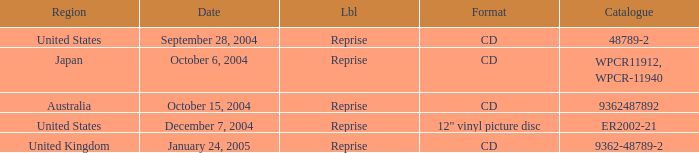What is the catalogue on october 15, 2004? 9362487892.0. Would you be able to parse every entry in this table? {'header': ['Region', 'Date', 'Lbl', 'Format', 'Catalogue'], 'rows': [['United States', 'September 28, 2004', 'Reprise', 'CD', '48789-2'], ['Japan', 'October 6, 2004', 'Reprise', 'CD', 'WPCR11912, WPCR-11940'], ['Australia', 'October 15, 2004', 'Reprise', 'CD', '9362487892'], ['United States', 'December 7, 2004', 'Reprise', '12" vinyl picture disc', 'ER2002-21'], ['United Kingdom', 'January 24, 2005', 'Reprise', 'CD', '9362-48789-2']]} 